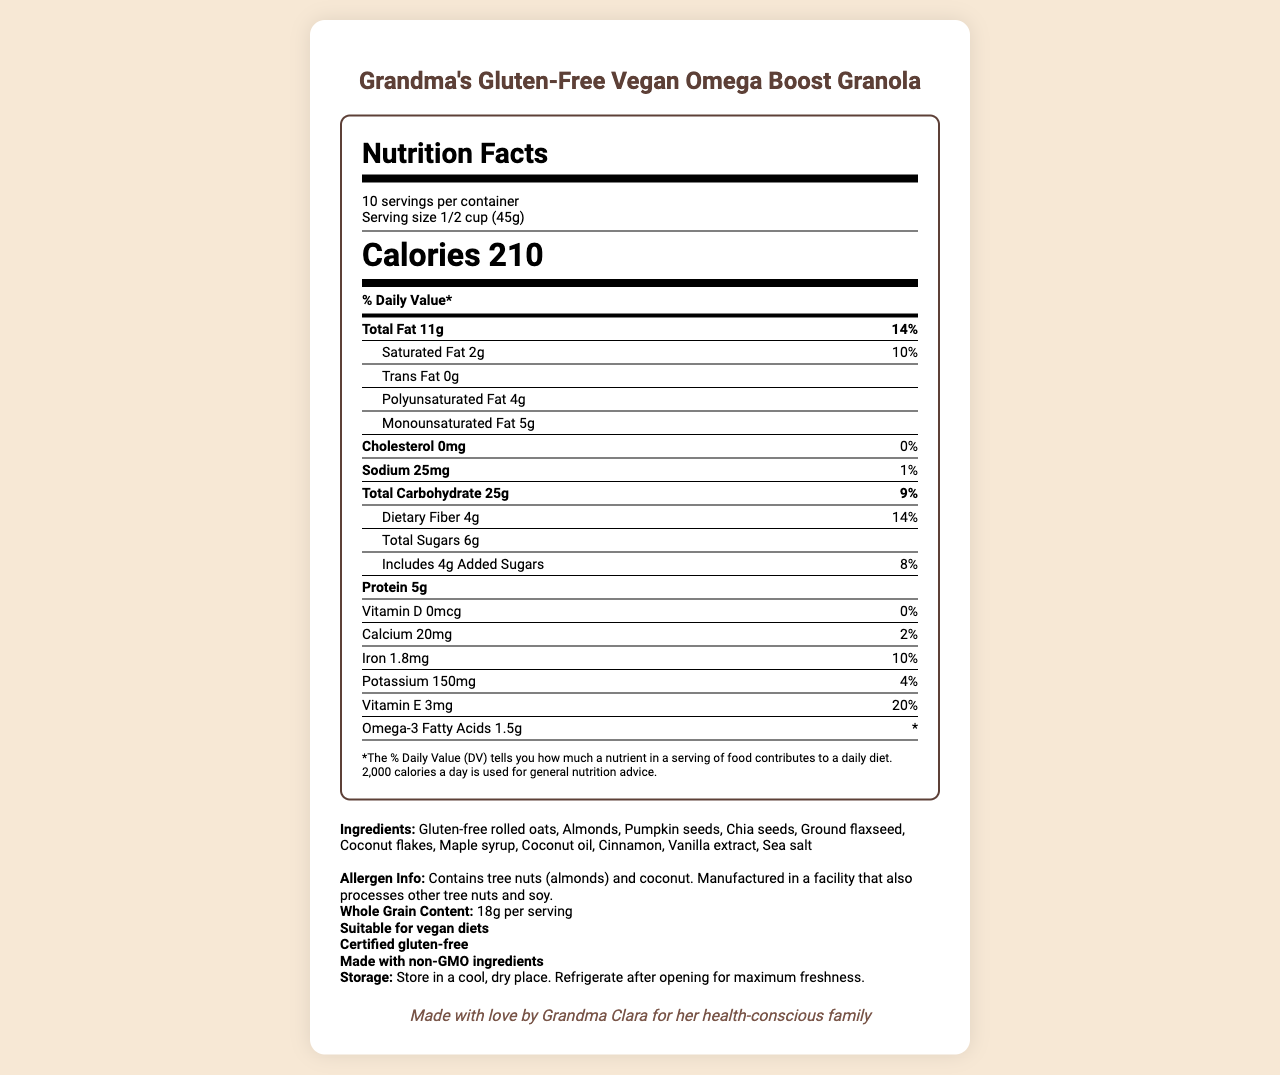what is the serving size? The serving size is mentioned at the beginning of the Nutrition Facts label under the title "Serving size".
Answer: 1/2 cup (45g) how many calories are in one serving? The calorie count per serving is prominently displayed in the Nutrition Facts label.
Answer: 210 how much omega-3 fatty acid is in each serving? The amount of omega-3 fatty acids per serving is listed towards the bottom of the Nutrition Facts label.
Answer: 1.5g are there any added sugars in the granola? The label specifies that there are 4g of added sugars in each serving.
Answer: Yes what is the total amount of fat in one serving? The label shows that each serving contains 11g of total fat.
Answer: 11g which ingredient is a source of omega-3 fatty acids? A. Almonds B. Chia seeds C. Vanilla extract D. Coconut oil Chia seeds are a known source of omega-3 fatty acids, and this ingredient is listed on the label.
Answer: B. Chia seeds what is the whole grain content per serving? The whole grain content per serving is listed in the "Ingredients" section of the document.
Answer: 18g is this granola gluten-free? The label includes a certification that the product is gluten-free.
Answer: Yes how much dietary fiber does one serving contain? The dietary fiber content is listed as 4g per serving in the Nutrition Facts label.
Answer: 4g which of the following is true about vitamin D in this granola? A. It provides 20% DV B. It provides 2% DV C. It provides 0% DV The label states that the granola provides 0% of the daily value for vitamin D.
Answer: C. It provides 0% DV does the product contain any cholesterol? The label clearly states that the product contains 0mg of cholesterol.
Answer: No how would you describe the overall document? The document provides a comprehensive overview of the granola's nutritional content along with additional information about ingredients, allergen warnings, and storage instructions, emphasizing its suitability for health-conscious and dietary-restricted consumers.
Answer: The document is a Nutrition Facts label for Grandma's Gluten-Free Vegan Omega Boost Granola, showcasing detailed nutritional information, ingredient list, allergen info, and several health claims including being gluten-free, vegan, and made with non-GMO ingredients. who is Grandma Clara? The document mentions a note from Grandma Clara, but it does not provide any further information about her identity or background.
Answer: Cannot be determined 